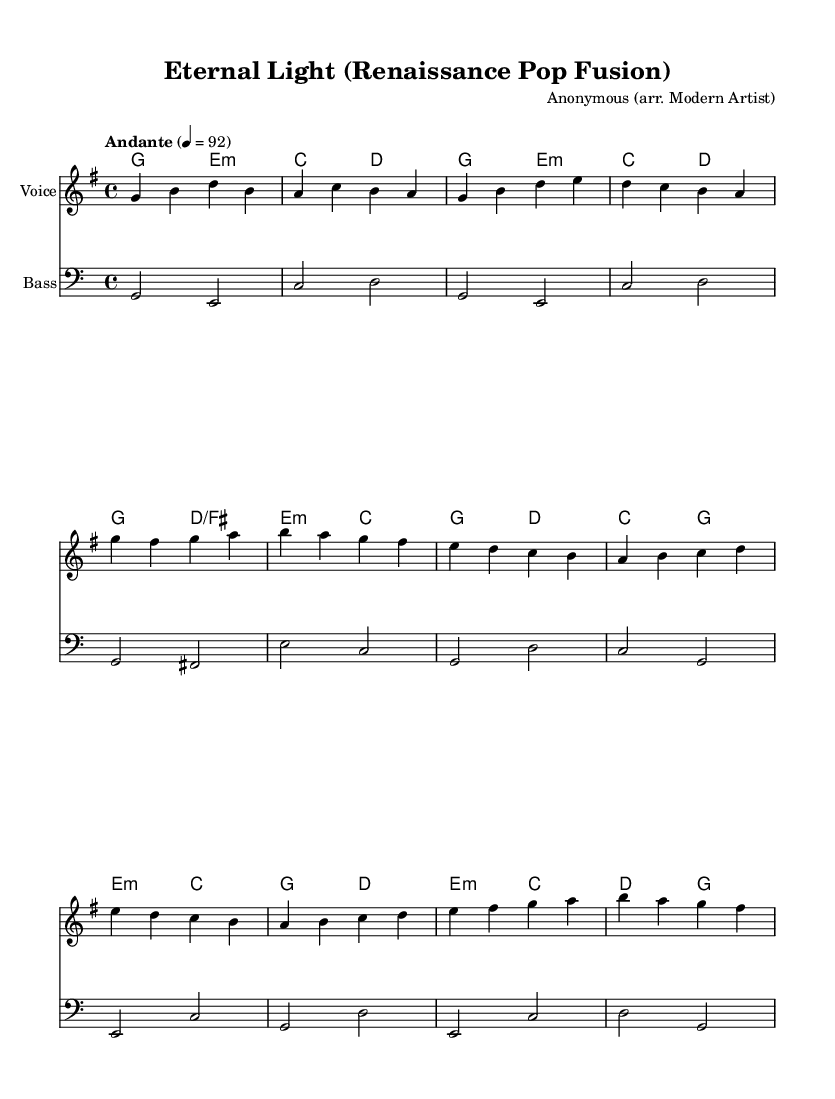What is the key signature of this music? The key signature, indicated at the beginning of the score, shows one sharp (F sharp), which means the piece is in G major.
Answer: G major What is the time signature of this piece? The time signature is located at the beginning of the score where it states "4/4", which means there are four beats in each measure and the quarter note gets one beat.
Answer: 4/4 What is the tempo marking for this score? The tempo marking is found after the time signature, stating "Andante" with a metronome marking of 4 = 92, indicating a moderate pace.
Answer: Andante How many measures are in the verse section? Counting the measures in the verse as written in the melody part, there are four measures that comprise this section.
Answer: Four What is the harmony structure for the chorus? By examining the chord mode section, the harmony structure consists of four chords for the chorus: G, E minor, C, and D.
Answer: G, E minor, C, D What is the last chord of the bridge section? Looking at the harmonies during the bridge, the last chord listed is "D", which appears in the last measure of this section.
Answer: D What modern musical elements can be noted in the arrangement? The use of pop-style vocal arrangements and a structured chorus indicates a contemporary influence, merging Renaissance styles with modern elements.
Answer: Pop-style vocal arrangements 